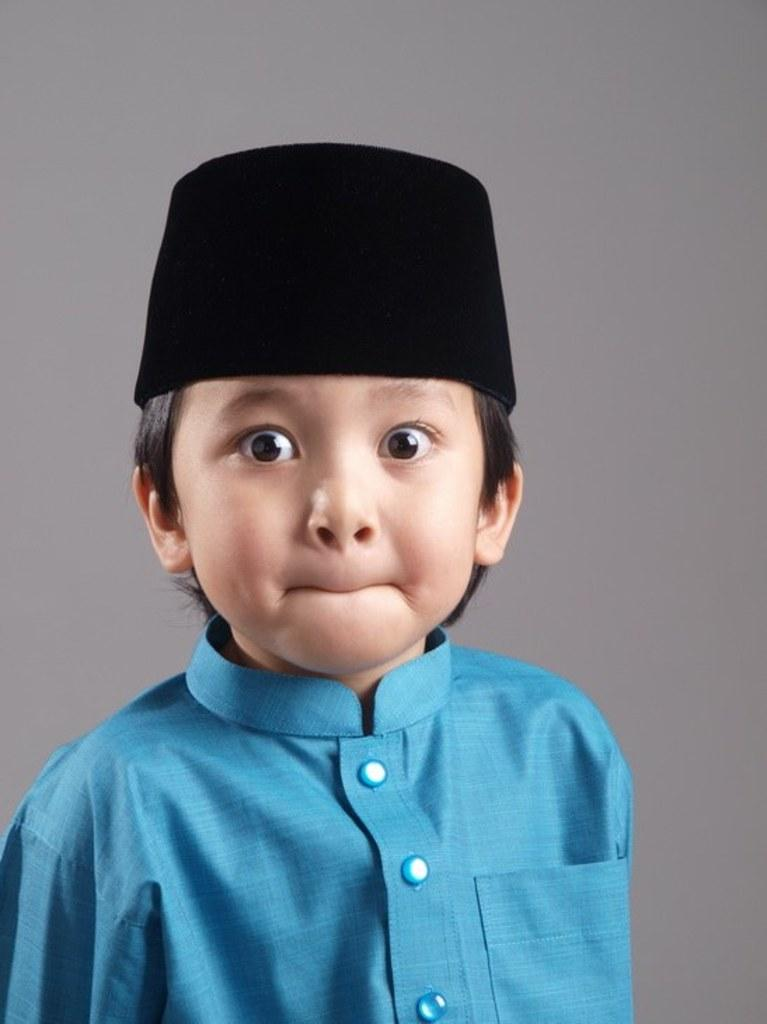What is the main subject of the image? There is a boy in the image. What is the boy doing with his lips? The boy has his lips compressed. What color is the dress the boy is wearing? The boy is wearing a blue dress. Can you see a kitten playing with the boy's dress in the image? There is no kitten present in the image. What is stopping the boy from moving in the image? The boy is not shown to be stopped or restricted in any way in the image. 